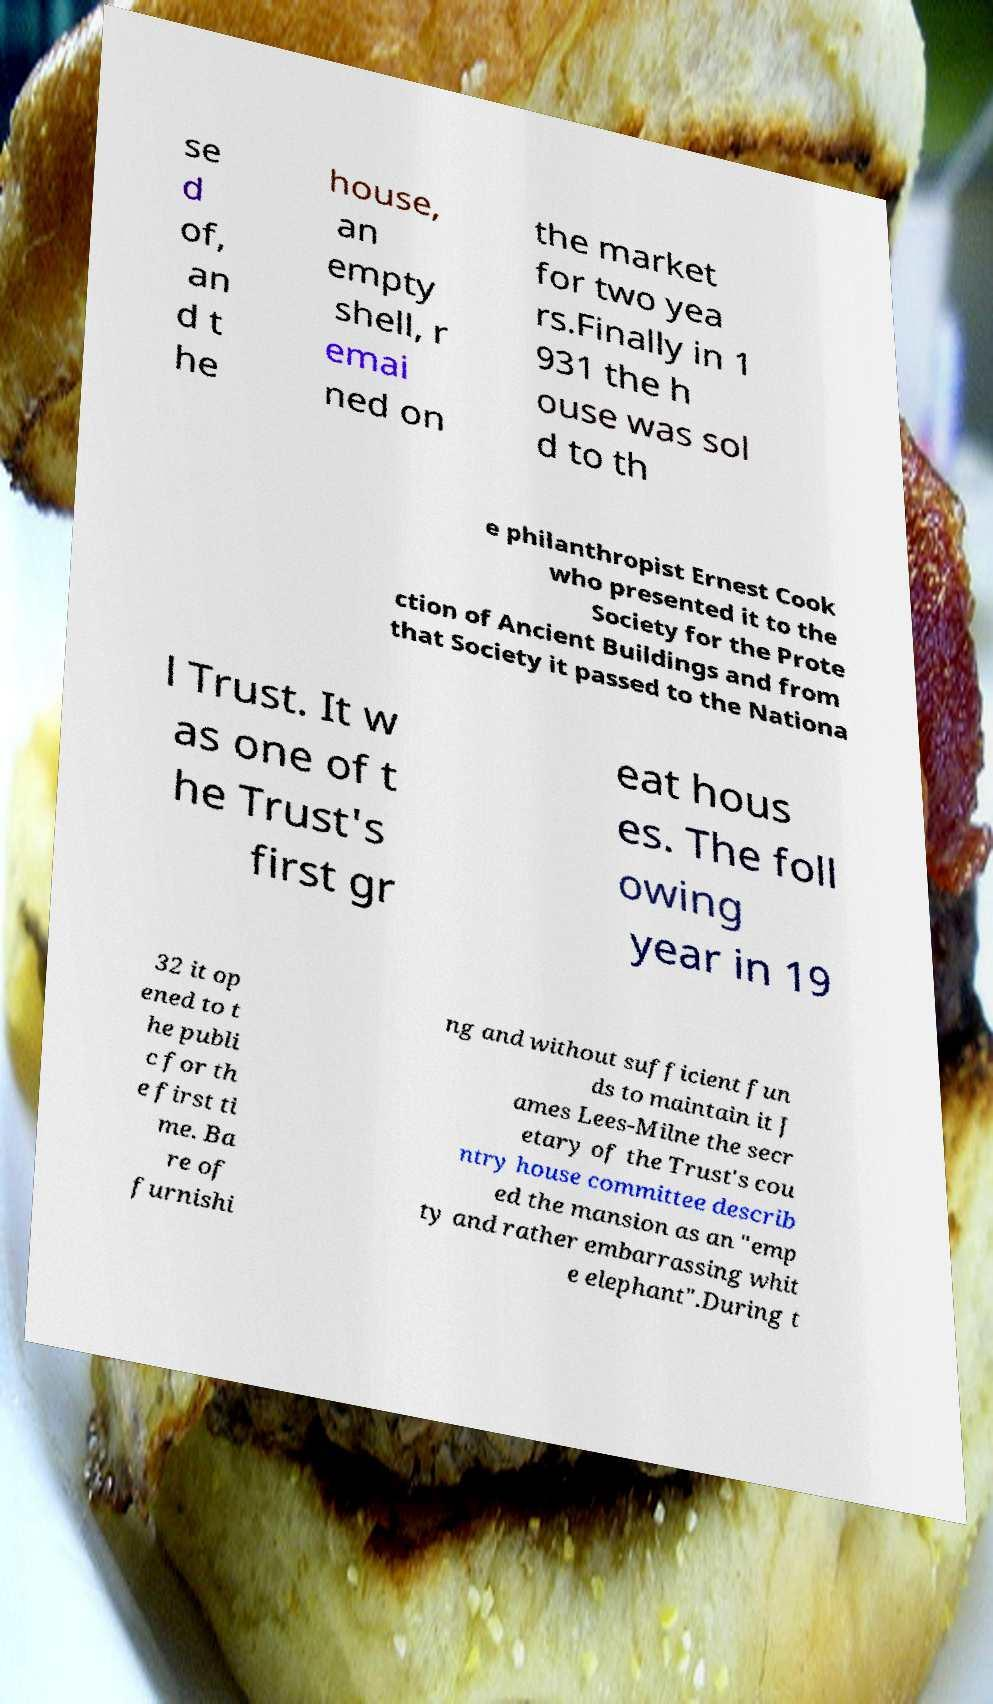Please read and relay the text visible in this image. What does it say? se d of, an d t he house, an empty shell, r emai ned on the market for two yea rs.Finally in 1 931 the h ouse was sol d to th e philanthropist Ernest Cook who presented it to the Society for the Prote ction of Ancient Buildings and from that Society it passed to the Nationa l Trust. It w as one of t he Trust's first gr eat hous es. The foll owing year in 19 32 it op ened to t he publi c for th e first ti me. Ba re of furnishi ng and without sufficient fun ds to maintain it J ames Lees-Milne the secr etary of the Trust's cou ntry house committee describ ed the mansion as an "emp ty and rather embarrassing whit e elephant".During t 